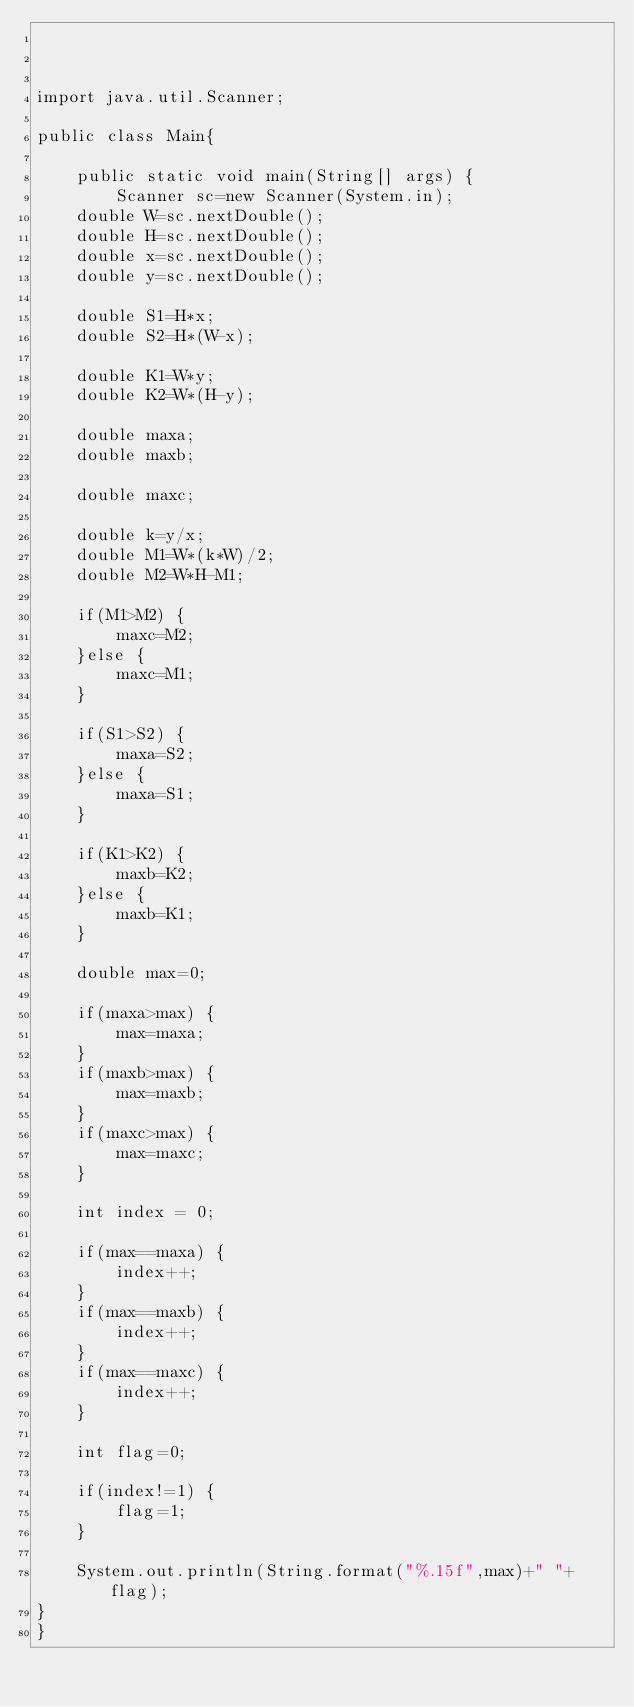Convert code to text. <code><loc_0><loc_0><loc_500><loc_500><_Java_>


import java.util.Scanner;

public class Main{
	
	public static void main(String[] args) {
		Scanner sc=new Scanner(System.in);
	double W=sc.nextDouble();
	double H=sc.nextDouble();
	double x=sc.nextDouble();
	double y=sc.nextDouble();
	
	double S1=H*x;
	double S2=H*(W-x);
	
	double K1=W*y;
	double K2=W*(H-y);
	
	double maxa;
	double maxb;
	
	double maxc;
	
	double k=y/x;
	double M1=W*(k*W)/2;
	double M2=W*H-M1;
	
	if(M1>M2) {
		maxc=M2;
	}else {
		maxc=M1;
	}
	
	if(S1>S2) {
		maxa=S2;
	}else {
		maxa=S1;
	}
	
	if(K1>K2) {
		maxb=K2;
	}else {
		maxb=K1;
	}
	
	double max=0;
	
	if(maxa>max) {
		max=maxa;
	}
	if(maxb>max) {
		max=maxb;
	}
	if(maxc>max) {
		max=maxc;
	}
	
	int index = 0;
	
	if(max==maxa) {
		index++;
	}
	if(max==maxb) {
		index++;
	}
	if(max==maxc) {
		index++;
	}
	
	int flag=0;
	
	if(index!=1) {
		flag=1;
	}
	
	System.out.println(String.format("%.15f",max)+" "+flag);
}
}</code> 